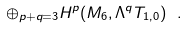<formula> <loc_0><loc_0><loc_500><loc_500>\oplus _ { p + q = 3 } H ^ { p } ( M _ { 6 } , \Lambda ^ { q } T _ { 1 , 0 } ) \ .</formula> 